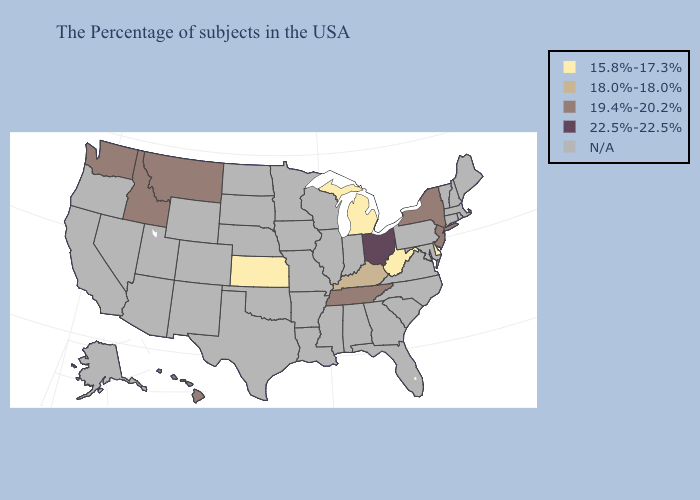What is the value of Georgia?
Write a very short answer. N/A. Does Michigan have the lowest value in the USA?
Write a very short answer. Yes. What is the lowest value in the Northeast?
Quick response, please. 19.4%-20.2%. What is the value of Virginia?
Concise answer only. N/A. Which states hav the highest value in the Northeast?
Be succinct. New York, New Jersey. Name the states that have a value in the range N/A?
Concise answer only. Maine, Massachusetts, Rhode Island, New Hampshire, Vermont, Connecticut, Maryland, Pennsylvania, Virginia, North Carolina, South Carolina, Florida, Georgia, Indiana, Alabama, Wisconsin, Illinois, Mississippi, Louisiana, Missouri, Arkansas, Minnesota, Iowa, Nebraska, Oklahoma, Texas, South Dakota, North Dakota, Wyoming, Colorado, New Mexico, Utah, Arizona, Nevada, California, Oregon, Alaska. Is the legend a continuous bar?
Be succinct. No. What is the value of West Virginia?
Keep it brief. 15.8%-17.3%. What is the lowest value in states that border New York?
Be succinct. 19.4%-20.2%. What is the highest value in the West ?
Be succinct. 19.4%-20.2%. What is the value of Michigan?
Keep it brief. 15.8%-17.3%. Among the states that border Wyoming , which have the highest value?
Write a very short answer. Montana, Idaho. 